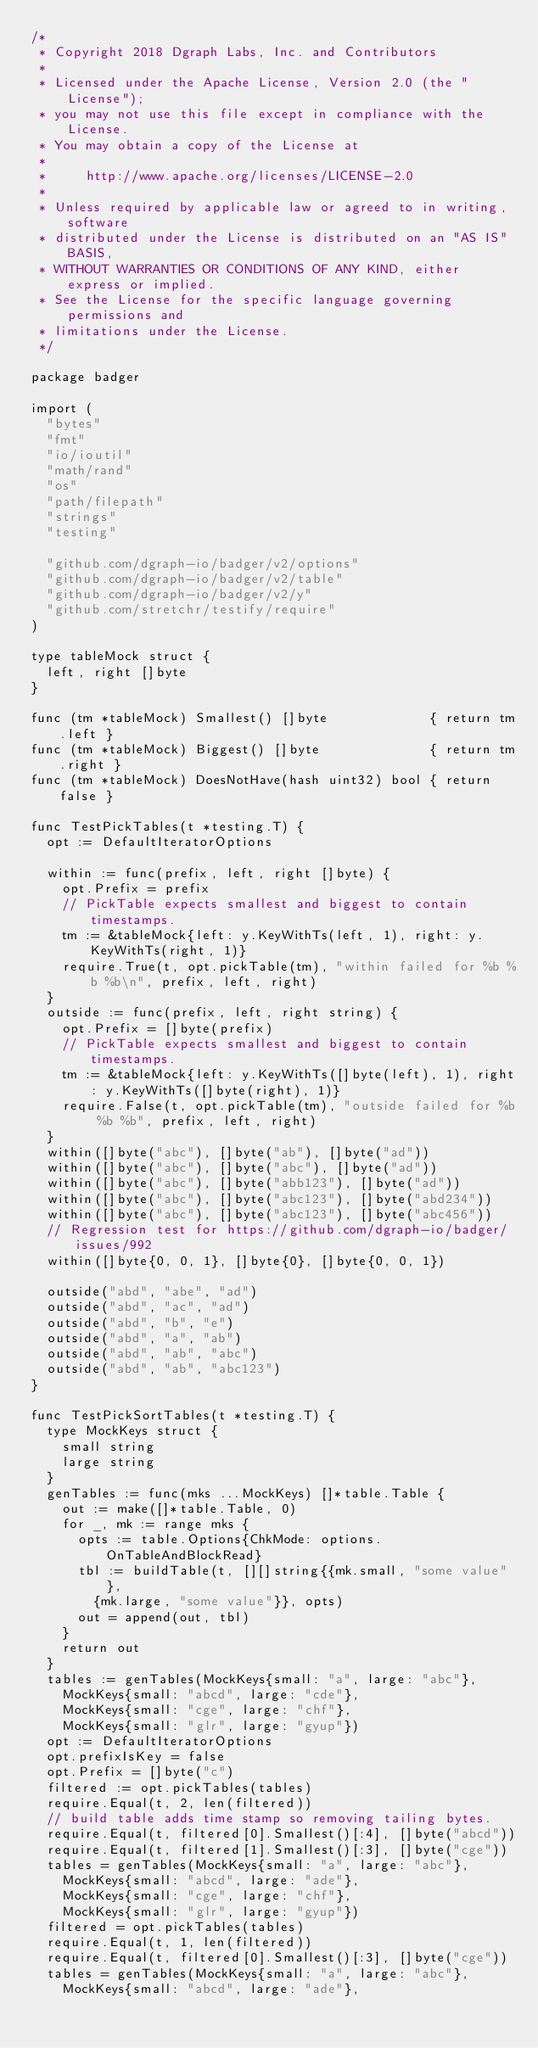<code> <loc_0><loc_0><loc_500><loc_500><_Go_>/*
 * Copyright 2018 Dgraph Labs, Inc. and Contributors
 *
 * Licensed under the Apache License, Version 2.0 (the "License");
 * you may not use this file except in compliance with the License.
 * You may obtain a copy of the License at
 *
 *     http://www.apache.org/licenses/LICENSE-2.0
 *
 * Unless required by applicable law or agreed to in writing, software
 * distributed under the License is distributed on an "AS IS" BASIS,
 * WITHOUT WARRANTIES OR CONDITIONS OF ANY KIND, either express or implied.
 * See the License for the specific language governing permissions and
 * limitations under the License.
 */

package badger

import (
	"bytes"
	"fmt"
	"io/ioutil"
	"math/rand"
	"os"
	"path/filepath"
	"strings"
	"testing"

	"github.com/dgraph-io/badger/v2/options"
	"github.com/dgraph-io/badger/v2/table"
	"github.com/dgraph-io/badger/v2/y"
	"github.com/stretchr/testify/require"
)

type tableMock struct {
	left, right []byte
}

func (tm *tableMock) Smallest() []byte             { return tm.left }
func (tm *tableMock) Biggest() []byte              { return tm.right }
func (tm *tableMock) DoesNotHave(hash uint32) bool { return false }

func TestPickTables(t *testing.T) {
	opt := DefaultIteratorOptions

	within := func(prefix, left, right []byte) {
		opt.Prefix = prefix
		// PickTable expects smallest and biggest to contain timestamps.
		tm := &tableMock{left: y.KeyWithTs(left, 1), right: y.KeyWithTs(right, 1)}
		require.True(t, opt.pickTable(tm), "within failed for %b %b %b\n", prefix, left, right)
	}
	outside := func(prefix, left, right string) {
		opt.Prefix = []byte(prefix)
		// PickTable expects smallest and biggest to contain timestamps.
		tm := &tableMock{left: y.KeyWithTs([]byte(left), 1), right: y.KeyWithTs([]byte(right), 1)}
		require.False(t, opt.pickTable(tm), "outside failed for %b %b %b", prefix, left, right)
	}
	within([]byte("abc"), []byte("ab"), []byte("ad"))
	within([]byte("abc"), []byte("abc"), []byte("ad"))
	within([]byte("abc"), []byte("abb123"), []byte("ad"))
	within([]byte("abc"), []byte("abc123"), []byte("abd234"))
	within([]byte("abc"), []byte("abc123"), []byte("abc456"))
	// Regression test for https://github.com/dgraph-io/badger/issues/992
	within([]byte{0, 0, 1}, []byte{0}, []byte{0, 0, 1})

	outside("abd", "abe", "ad")
	outside("abd", "ac", "ad")
	outside("abd", "b", "e")
	outside("abd", "a", "ab")
	outside("abd", "ab", "abc")
	outside("abd", "ab", "abc123")
}

func TestPickSortTables(t *testing.T) {
	type MockKeys struct {
		small string
		large string
	}
	genTables := func(mks ...MockKeys) []*table.Table {
		out := make([]*table.Table, 0)
		for _, mk := range mks {
			opts := table.Options{ChkMode: options.OnTableAndBlockRead}
			tbl := buildTable(t, [][]string{{mk.small, "some value"},
				{mk.large, "some value"}}, opts)
			out = append(out, tbl)
		}
		return out
	}
	tables := genTables(MockKeys{small: "a", large: "abc"},
		MockKeys{small: "abcd", large: "cde"},
		MockKeys{small: "cge", large: "chf"},
		MockKeys{small: "glr", large: "gyup"})
	opt := DefaultIteratorOptions
	opt.prefixIsKey = false
	opt.Prefix = []byte("c")
	filtered := opt.pickTables(tables)
	require.Equal(t, 2, len(filtered))
	// build table adds time stamp so removing tailing bytes.
	require.Equal(t, filtered[0].Smallest()[:4], []byte("abcd"))
	require.Equal(t, filtered[1].Smallest()[:3], []byte("cge"))
	tables = genTables(MockKeys{small: "a", large: "abc"},
		MockKeys{small: "abcd", large: "ade"},
		MockKeys{small: "cge", large: "chf"},
		MockKeys{small: "glr", large: "gyup"})
	filtered = opt.pickTables(tables)
	require.Equal(t, 1, len(filtered))
	require.Equal(t, filtered[0].Smallest()[:3], []byte("cge"))
	tables = genTables(MockKeys{small: "a", large: "abc"},
		MockKeys{small: "abcd", large: "ade"},</code> 